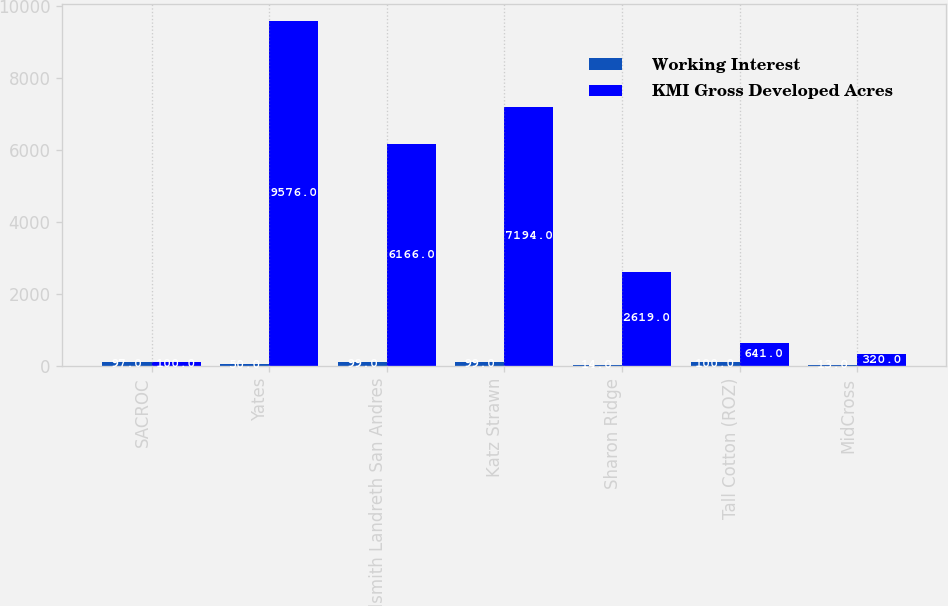Convert chart to OTSL. <chart><loc_0><loc_0><loc_500><loc_500><stacked_bar_chart><ecel><fcel>SACROC<fcel>Yates<fcel>Goldsmith Landreth San Andres<fcel>Katz Strawn<fcel>Sharon Ridge<fcel>Tall Cotton (ROZ)<fcel>MidCross<nl><fcel>Working Interest<fcel>97<fcel>50<fcel>99<fcel>99<fcel>14<fcel>100<fcel>13<nl><fcel>KMI Gross Developed Acres<fcel>100<fcel>9576<fcel>6166<fcel>7194<fcel>2619<fcel>641<fcel>320<nl></chart> 